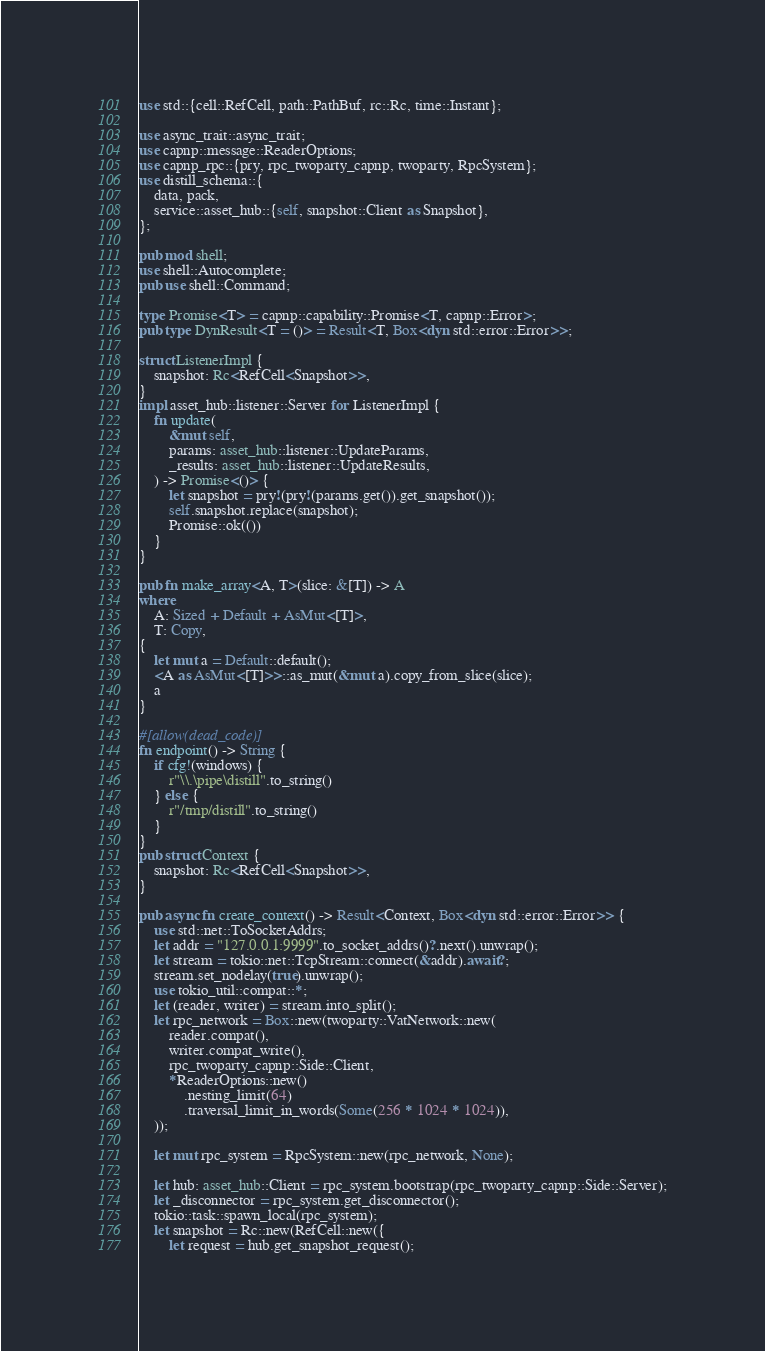Convert code to text. <code><loc_0><loc_0><loc_500><loc_500><_Rust_>use std::{cell::RefCell, path::PathBuf, rc::Rc, time::Instant};

use async_trait::async_trait;
use capnp::message::ReaderOptions;
use capnp_rpc::{pry, rpc_twoparty_capnp, twoparty, RpcSystem};
use distill_schema::{
    data, pack,
    service::asset_hub::{self, snapshot::Client as Snapshot},
};

pub mod shell;
use shell::Autocomplete;
pub use shell::Command;

type Promise<T> = capnp::capability::Promise<T, capnp::Error>;
pub type DynResult<T = ()> = Result<T, Box<dyn std::error::Error>>;

struct ListenerImpl {
    snapshot: Rc<RefCell<Snapshot>>,
}
impl asset_hub::listener::Server for ListenerImpl {
    fn update(
        &mut self,
        params: asset_hub::listener::UpdateParams,
        _results: asset_hub::listener::UpdateResults,
    ) -> Promise<()> {
        let snapshot = pry!(pry!(params.get()).get_snapshot());
        self.snapshot.replace(snapshot);
        Promise::ok(())
    }
}

pub fn make_array<A, T>(slice: &[T]) -> A
where
    A: Sized + Default + AsMut<[T]>,
    T: Copy,
{
    let mut a = Default::default();
    <A as AsMut<[T]>>::as_mut(&mut a).copy_from_slice(slice);
    a
}

#[allow(dead_code)]
fn endpoint() -> String {
    if cfg!(windows) {
        r"\\.\pipe\distill".to_string()
    } else {
        r"/tmp/distill".to_string()
    }
}
pub struct Context {
    snapshot: Rc<RefCell<Snapshot>>,
}

pub async fn create_context() -> Result<Context, Box<dyn std::error::Error>> {
    use std::net::ToSocketAddrs;
    let addr = "127.0.0.1:9999".to_socket_addrs()?.next().unwrap();
    let stream = tokio::net::TcpStream::connect(&addr).await?;
    stream.set_nodelay(true).unwrap();
    use tokio_util::compat::*;
    let (reader, writer) = stream.into_split();
    let rpc_network = Box::new(twoparty::VatNetwork::new(
        reader.compat(),
        writer.compat_write(),
        rpc_twoparty_capnp::Side::Client,
        *ReaderOptions::new()
            .nesting_limit(64)
            .traversal_limit_in_words(Some(256 * 1024 * 1024)),
    ));

    let mut rpc_system = RpcSystem::new(rpc_network, None);

    let hub: asset_hub::Client = rpc_system.bootstrap(rpc_twoparty_capnp::Side::Server);
    let _disconnector = rpc_system.get_disconnector();
    tokio::task::spawn_local(rpc_system);
    let snapshot = Rc::new(RefCell::new({
        let request = hub.get_snapshot_request();</code> 